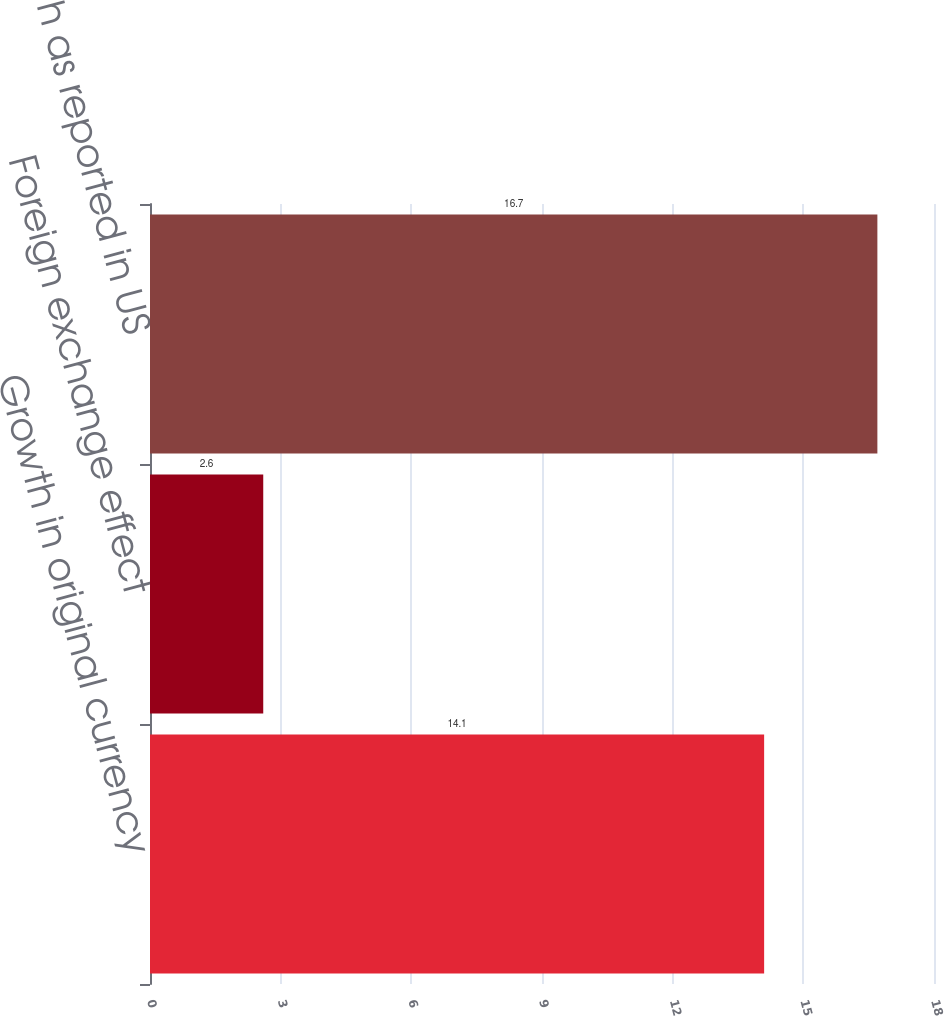Convert chart to OTSL. <chart><loc_0><loc_0><loc_500><loc_500><bar_chart><fcel>Growth in original currency<fcel>Foreign exchange effect<fcel>Growth as reported in US<nl><fcel>14.1<fcel>2.6<fcel>16.7<nl></chart> 